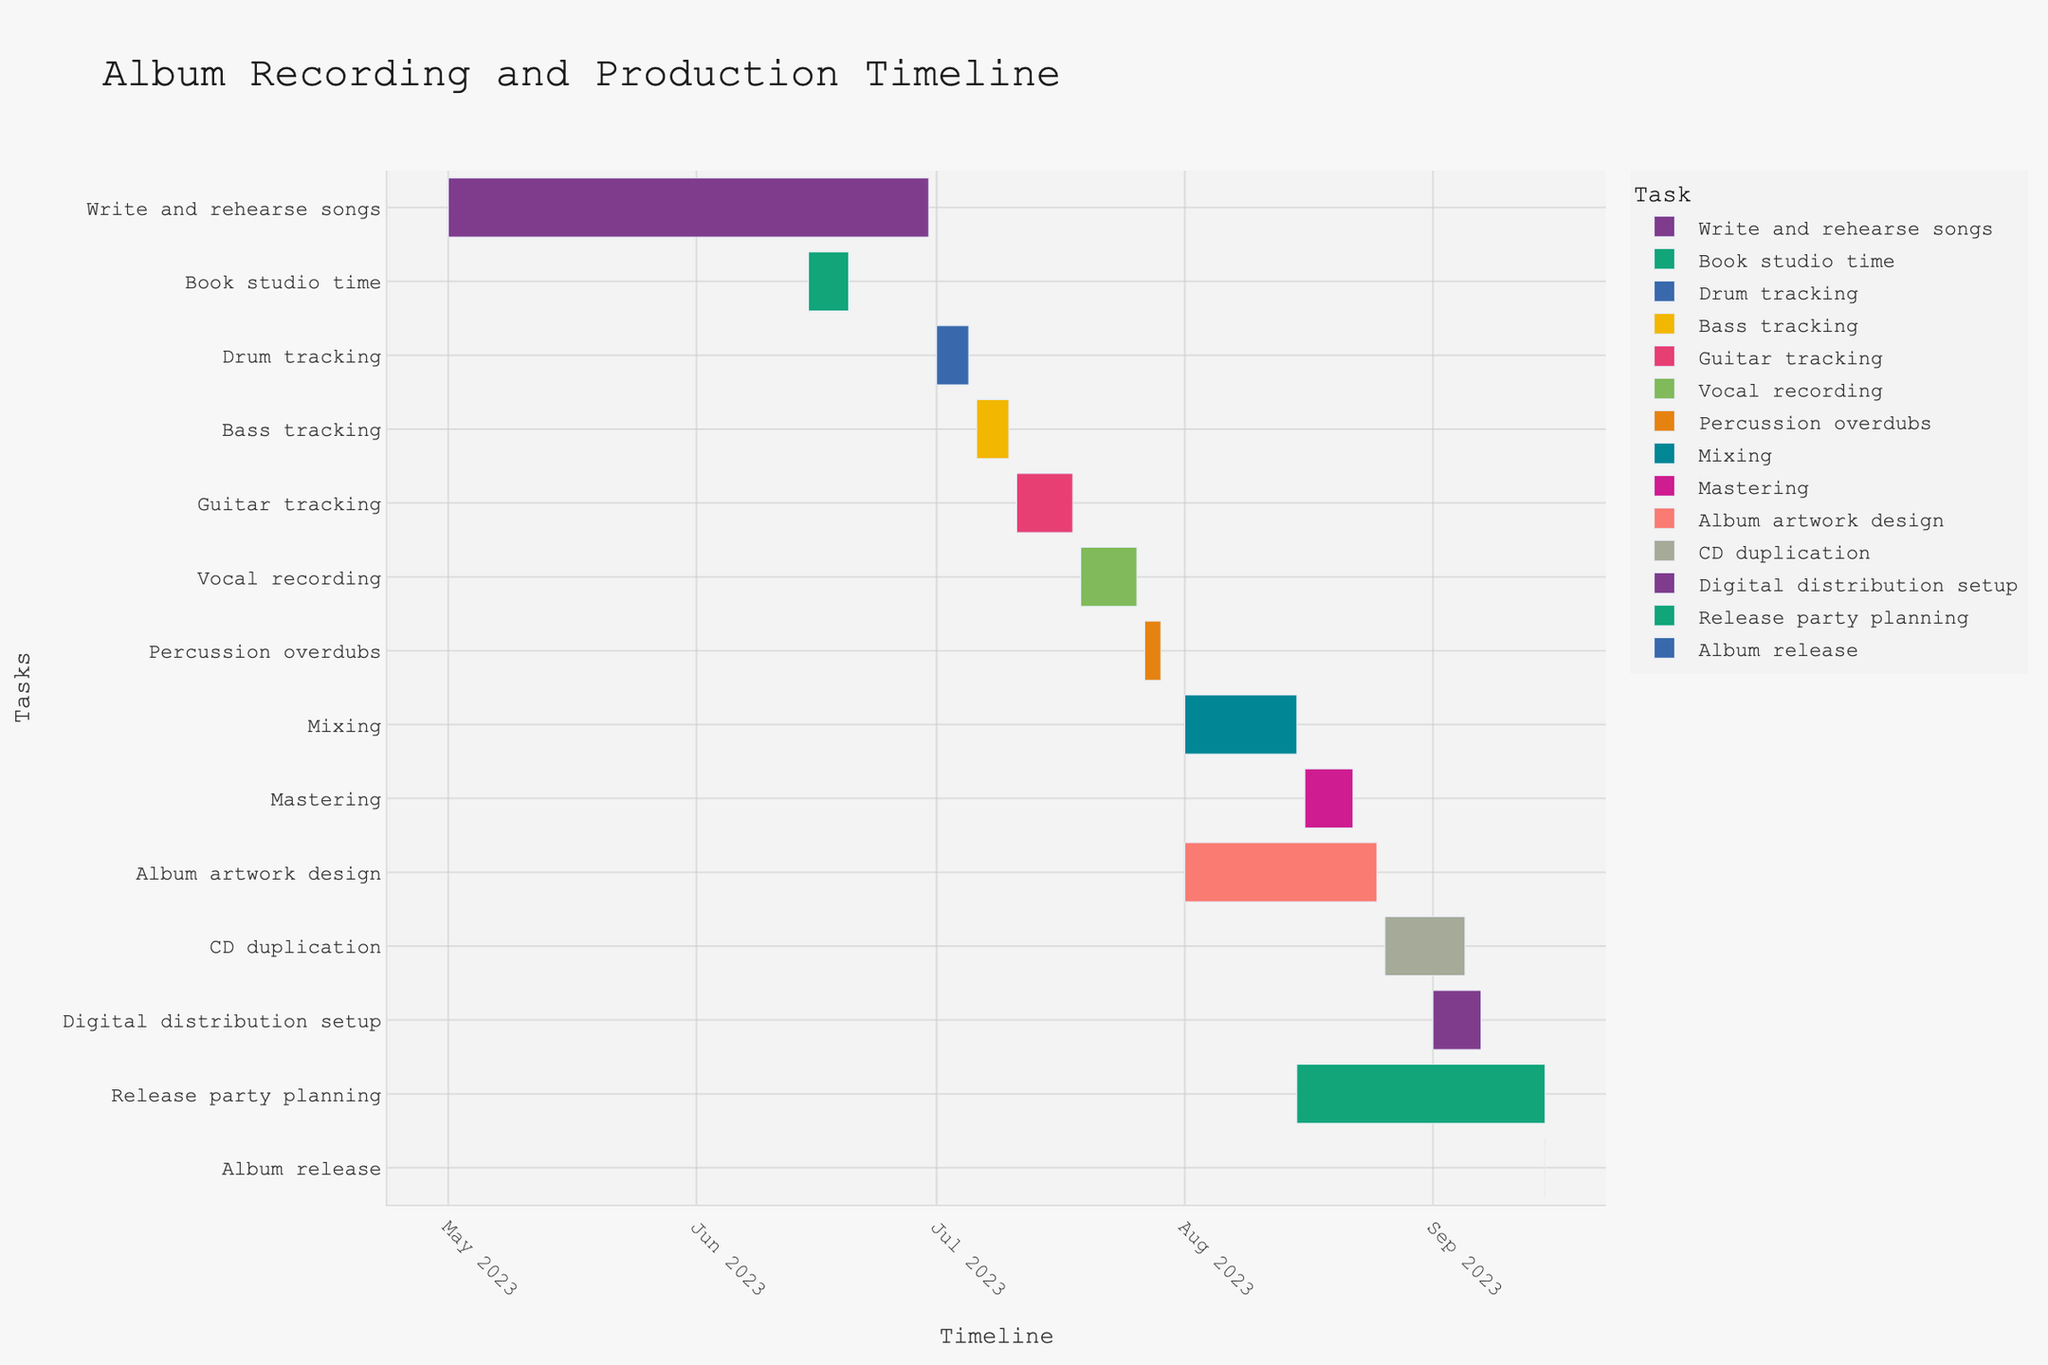What is the title of the Gantt chart? The title is found at the top of the chart. It reads "Album Recording and Production Timeline".
Answer: Album Recording and Production Timeline What are the start and end dates for the "Drum tracking" task? The "Drum tracking" task bar starts at July 1, 2023, and ends at July 5, 2023.
Answer: July 1, 2023, and July 5, 2023 Which task starts immediately after "Bass tracking"? By looking at the timeline order, "Guitar tracking" starts right after "Bass tracking" ends.
Answer: Guitar tracking How long does "Mixing" take? "Mixing" spans from August 1, 2023, to August 15, 2023. Subtracting the start date from the end date, the duration is calculated as August 15 - August 1 = 14 days.
Answer: 14 days What tasks are ongoing during the month of August 2023? Inspecting the Gantt chart's timeline running through the month of August 2023, the tasks visible are Mixing, Album artwork design, CD duplication, and Release party planning.
Answer: Mixing, Album artwork design, CD duplication, Release party planning Which task has the shortest duration? The chart shows durations for each task visually; "Book studio time" and "Album release" appear to be the shortest, both lasting only 1 day.
Answer: Book studio time, Album release What's the total duration from the start of "Write and rehearse songs" to the end of "Digital distribution setup"? "Write and rehearse songs" starts on May 1, 2023, and "Digital distribution setup" ends on September 7, 2023. Calculating the duration between these dates yields a total span of May 1 to September 7. First, find the days from May to August (May: 31, June: 30, July: 31, August: 31), then add September's 7 days: 31 + 30 + 31 + 31 + 7 = 130 days.
Answer: 130 days How do the durations of "Vocal recording" and "Percussion overdubs" compare? "Vocal recording" runs from July 19, 2023, to July 26, 2023 (7 days), while "Percussion overdubs" runs from July 27, 2023, to July 29, 2023 (3 days). Therefore, "Vocal recording" is longer than "Percussion overdubs".
Answer: Vocal recording is longer What tasks overlap with "Album artwork design"? The task "Album artwork design" overlaps with Mixing (Aug 1-15), Mastering (Aug 16-22), CD duplication (Aug 26-Sept 5), Digital distribution setup (Sept 1-7), and Release party planning (Aug 15-Sept 15).
Answer: Mixing, Mastering, CD duplication, Digital distribution setup, Release party planning Which month has the most diverse set of tasks being conducted? By analyzing the chart, August appears to have the most diverse set of tasks: Mixing, Mastering, Album artwork design, CD duplication, and Release party planning.
Answer: August 